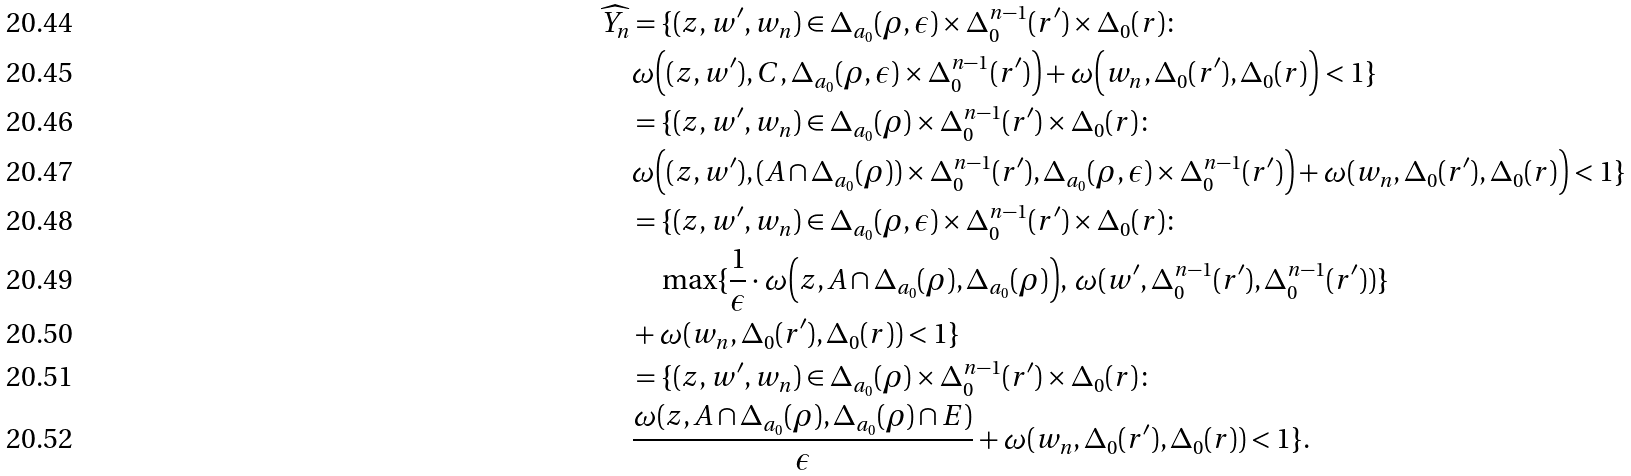<formula> <loc_0><loc_0><loc_500><loc_500>\widehat { Y _ { n } } & = \{ ( z , w ^ { \prime } , w _ { n } ) \in \Delta _ { a _ { 0 } } ( \rho , \epsilon ) \times \Delta _ { 0 } ^ { n - 1 } ( r ^ { \prime } ) \times \Delta _ { 0 } ( r ) \colon \\ & \omega \Big ( ( z , w ^ { \prime } ) , C , \Delta _ { a _ { 0 } } ( \rho , \epsilon ) \times \Delta _ { 0 } ^ { n - 1 } ( r ^ { \prime } ) \Big ) + \omega \Big ( w _ { n } , \Delta _ { 0 } ( r ^ { \prime } ) , \Delta _ { 0 } ( r ) \Big ) < 1 \} \\ & = \{ ( z , w ^ { \prime } , w _ { n } ) \in \Delta _ { a _ { 0 } } ( \rho ) \times \Delta _ { 0 } ^ { n - 1 } ( r ^ { \prime } ) \times \Delta _ { 0 } ( r ) \colon \\ & \omega \Big ( ( z , w ^ { \prime } ) , ( A \cap \Delta _ { a _ { 0 } } ( \rho ) ) \times \Delta _ { 0 } ^ { n - 1 } ( r ^ { \prime } ) , \Delta _ { a _ { 0 } } ( \rho , \epsilon ) \times \Delta _ { 0 } ^ { n - 1 } ( r ^ { \prime } ) \Big ) + \omega ( w _ { n } , \Delta _ { 0 } ( r ^ { \prime } ) , \Delta _ { 0 } ( r ) \Big ) < 1 \} \\ & = \{ ( z , w ^ { \prime } , w _ { n } ) \in \Delta _ { a _ { 0 } } ( \rho , \epsilon ) \times \Delta _ { 0 } ^ { n - 1 } ( r ^ { \prime } ) \times \Delta _ { 0 } ( r ) \colon \\ & \quad \max \{ \frac { 1 } { \epsilon } \cdot \omega \Big ( z , A \cap \Delta _ { a _ { 0 } } ( \rho ) , \Delta _ { a _ { 0 } } ( \rho ) \Big ) , \, \omega ( w ^ { \prime } , \Delta _ { 0 } ^ { n - 1 } ( r ^ { \prime } ) , \Delta _ { 0 } ^ { n - 1 } ( r ^ { \prime } ) ) \} \\ & + \omega ( w _ { n } , \Delta _ { 0 } ( r ^ { \prime } ) , \Delta _ { 0 } ( r ) ) < 1 \} \\ & = \{ ( z , w ^ { \prime } , w _ { n } ) \in \Delta _ { a _ { 0 } } ( \rho ) \times \Delta _ { 0 } ^ { n - 1 } ( r ^ { \prime } ) \times \Delta _ { 0 } ( r ) \colon \\ & \frac { \omega ( z , A \cap \Delta _ { a _ { 0 } } ( \rho ) , \Delta _ { a _ { 0 } } ( \rho ) \cap E ) } { \epsilon } + \omega ( w _ { n } , \Delta _ { 0 } ( r ^ { \prime } ) , \Delta _ { 0 } ( r ) ) < 1 \} .</formula> 